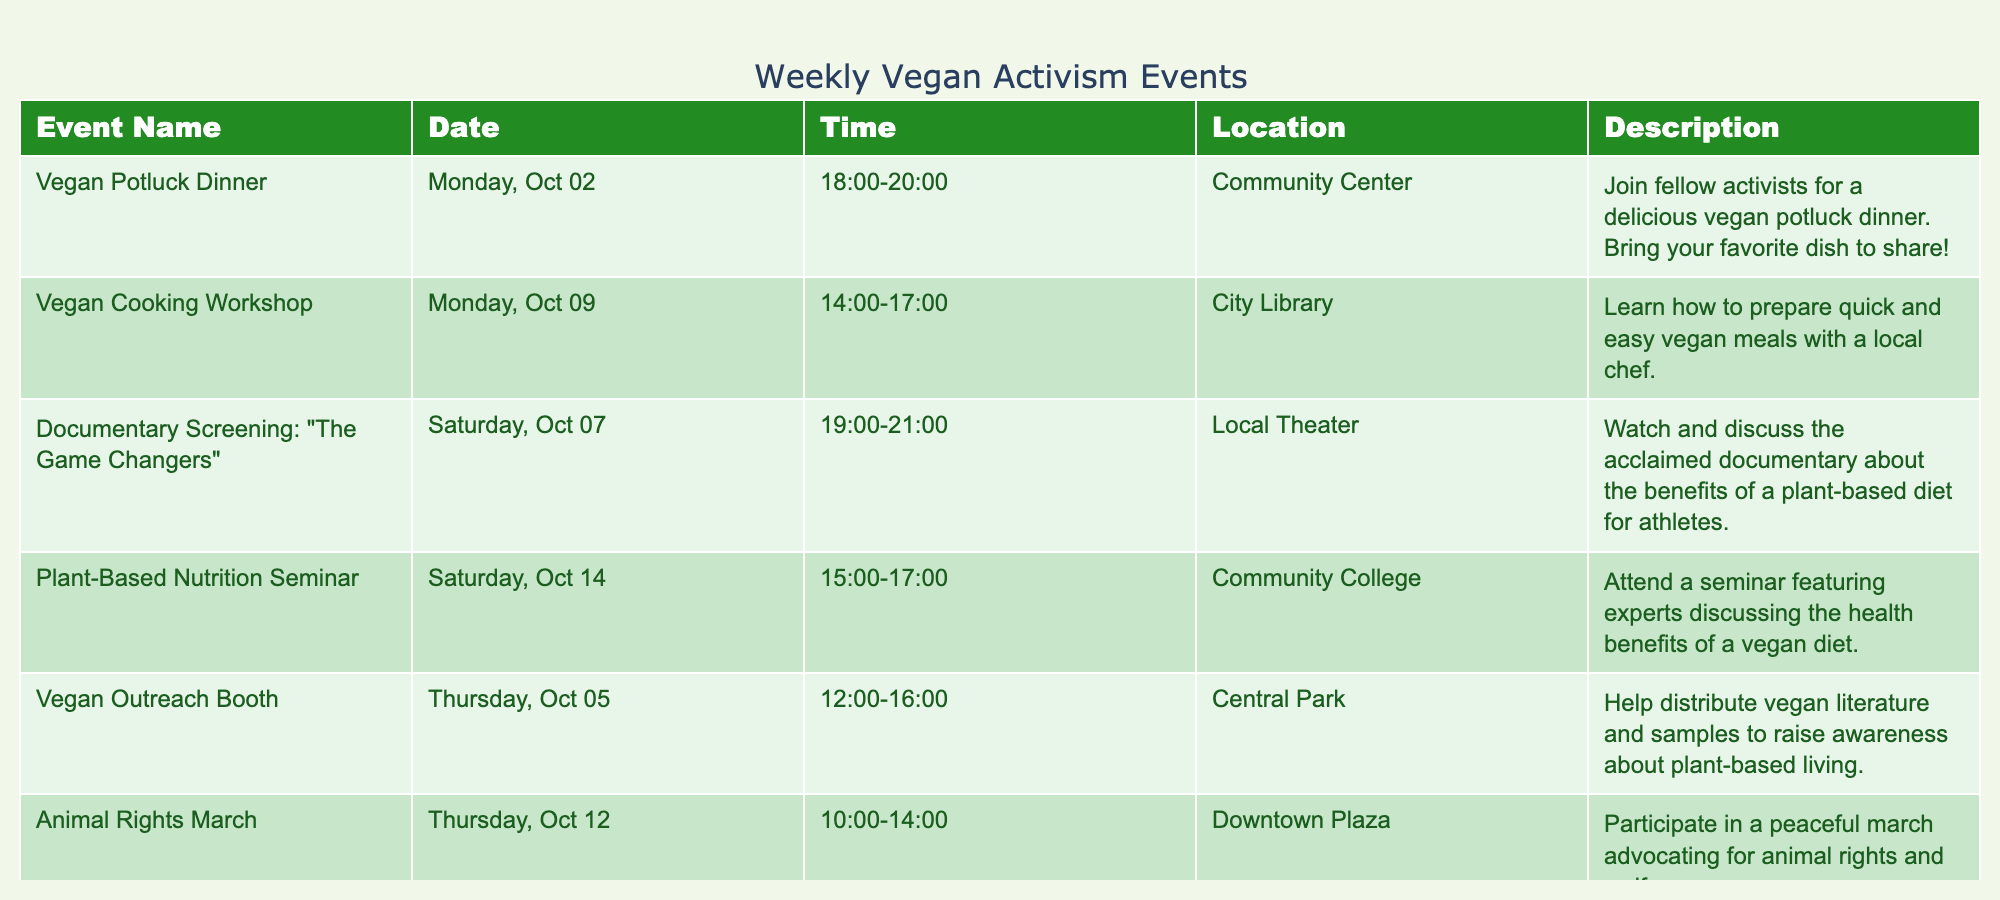What is the date of the Vegan Potluck Dinner? The table lists the Vegan Potluck Dinner event, which is set for October 2, 2023. I can find the event name in the first column and check its corresponding date in the second column.
Answer: October 2, 2023 Which event takes place on October 5, 2023? By looking at the date column, I can find the event that matches October 5, 2023. The Vegan Outreach Booth is scheduled for that date.
Answer: Vegan Outreach Booth How many events are scheduled for the week of October 9 to October 15? I will identify the events listed between October 9 and October 15 by checking their dates in the table. The Vegan Cooking Workshop on October 9, and the Plant-Based Nutrition Seminar on October 14 make a total of 2 events.
Answer: 2 Is there an event focused on animal rights? I can check the description column for any mention of animal rights. The Animal Rights March is mentioned, confirming that there is indeed an event focused on this cause.
Answer: Yes What is the time duration of the Animal Rights March? Look at the time column for the Animal Rights March to determine its duration. It runs from 10:00 to 14:00, which is a span of 4 hours. Taking the end time, I subtract the start time: 14:00 - 10:00 = 4 hours.
Answer: 4 hours What is the average time duration for the events listed? I will first convert all event times to a 24-hour format and calculate the duration for each: Vegan Potluck Dinner (2 hours), Vegan Outreach Booth (4 hours), Documentary Screening (2 hours), Cooking Workshop (3 hours), Animal Rights March (4 hours), Nutrition Seminar (2 hours), Planning Meeting (2 hours). Adding these gives a total duration of 19 hours. Since there are 7 events, the average duration is 19 hours / 7 = approx. 2.71 hours.
Answer: Approx. 2.71 hours Which event has the longest duration? I will determine the duration for each event. The Animal Rights March is from 10:00 to 14:00 (4 hours), while the other events have shorter durations. After checking all events, it is clear that the Animal Rights March has the longest duration.
Answer: Animal Rights March Are there any events scheduled on weekends? Looking through the dates of the events, October 7 and October 14 are Saturdays. The events on these days are the Documentary Screening and the Plant-Based Nutrition Seminar respectively. Therefore, there are events scheduled on weekends.
Answer: Yes 